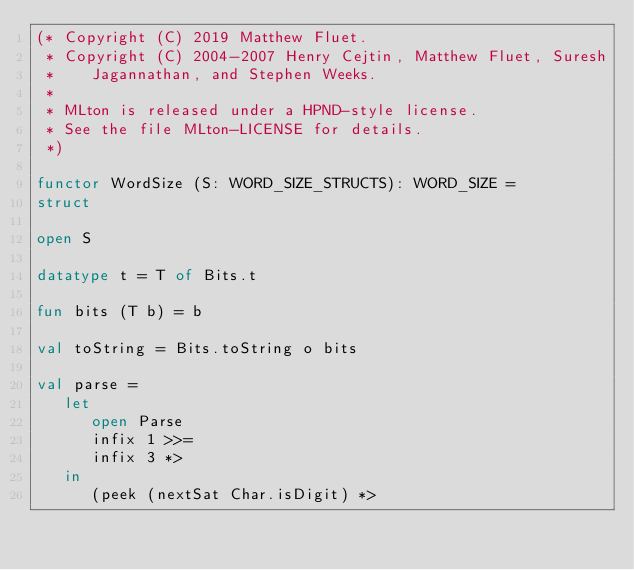<code> <loc_0><loc_0><loc_500><loc_500><_SML_>(* Copyright (C) 2019 Matthew Fluet.
 * Copyright (C) 2004-2007 Henry Cejtin, Matthew Fluet, Suresh
 *    Jagannathan, and Stephen Weeks.
 *
 * MLton is released under a HPND-style license.
 * See the file MLton-LICENSE for details.
 *)

functor WordSize (S: WORD_SIZE_STRUCTS): WORD_SIZE =
struct

open S

datatype t = T of Bits.t

fun bits (T b) = b

val toString = Bits.toString o bits

val parse =
   let
      open Parse
      infix 1 >>=
      infix 3 *>
   in
      (peek (nextSat Char.isDigit) *></code> 